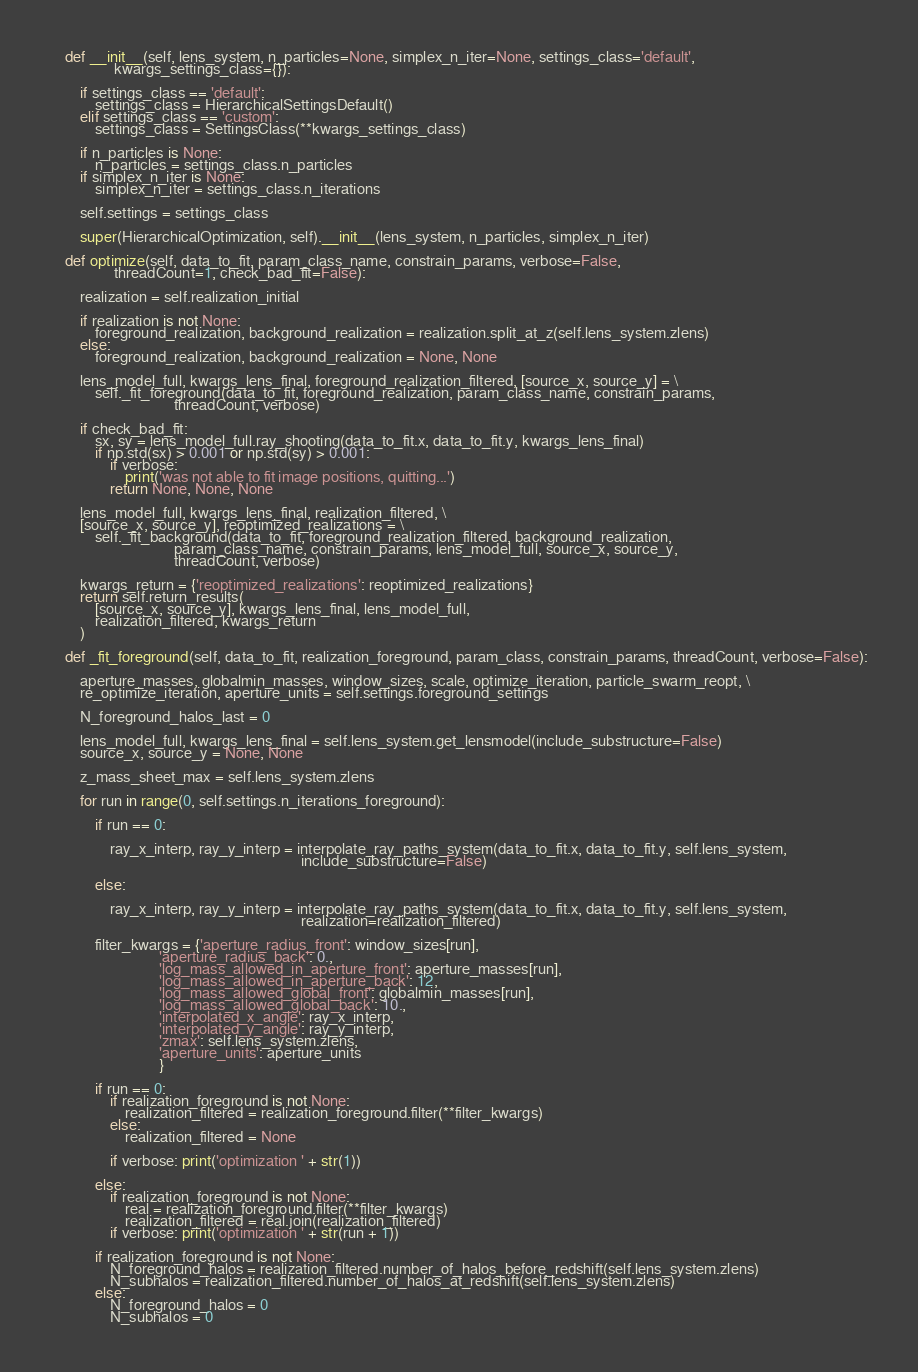<code> <loc_0><loc_0><loc_500><loc_500><_Python_>
    def __init__(self, lens_system, n_particles=None, simplex_n_iter=None, settings_class='default',
                 kwargs_settings_class={}):

        if settings_class == 'default':
            settings_class = HierarchicalSettingsDefault()
        elif settings_class == 'custom':
            settings_class = SettingsClass(**kwargs_settings_class)

        if n_particles is None:
            n_particles = settings_class.n_particles
        if simplex_n_iter is None:
            simplex_n_iter = settings_class.n_iterations

        self.settings = settings_class

        super(HierarchicalOptimization, self).__init__(lens_system, n_particles, simplex_n_iter)

    def optimize(self, data_to_fit, param_class_name, constrain_params, verbose=False,
                 threadCount=1, check_bad_fit=False):

        realization = self.realization_initial

        if realization is not None:
            foreground_realization, background_realization = realization.split_at_z(self.lens_system.zlens)
        else:
            foreground_realization, background_realization = None, None

        lens_model_full, kwargs_lens_final, foreground_realization_filtered, [source_x, source_y] = \
            self._fit_foreground(data_to_fit, foreground_realization, param_class_name, constrain_params,
                                 threadCount, verbose)

        if check_bad_fit:
            sx, sy = lens_model_full.ray_shooting(data_to_fit.x, data_to_fit.y, kwargs_lens_final)
            if np.std(sx) > 0.001 or np.std(sy) > 0.001:
                if verbose:
                    print('was not able to fit image positions, quitting...')
                return None, None, None

        lens_model_full, kwargs_lens_final, realization_filtered, \
        [source_x, source_y], reoptimized_realizations = \
            self._fit_background(data_to_fit, foreground_realization_filtered, background_realization,
                                 param_class_name, constrain_params, lens_model_full, source_x, source_y,
                                 threadCount, verbose)

        kwargs_return = {'reoptimized_realizations': reoptimized_realizations}
        return self.return_results(
            [source_x, source_y], kwargs_lens_final, lens_model_full,
            realization_filtered, kwargs_return
        )

    def _fit_foreground(self, data_to_fit, realization_foreground, param_class, constrain_params, threadCount, verbose=False):

        aperture_masses, globalmin_masses, window_sizes, scale, optimize_iteration, particle_swarm_reopt, \
        re_optimize_iteration, aperture_units = self.settings.foreground_settings

        N_foreground_halos_last = 0

        lens_model_full, kwargs_lens_final = self.lens_system.get_lensmodel(include_substructure=False)
        source_x, source_y = None, None

        z_mass_sheet_max = self.lens_system.zlens

        for run in range(0, self.settings.n_iterations_foreground):

            if run == 0:

                ray_x_interp, ray_y_interp = interpolate_ray_paths_system(data_to_fit.x, data_to_fit.y, self.lens_system,
                                                                   include_substructure=False)

            else:

                ray_x_interp, ray_y_interp = interpolate_ray_paths_system(data_to_fit.x, data_to_fit.y, self.lens_system,
                                                                   realization=realization_filtered)

            filter_kwargs = {'aperture_radius_front': window_sizes[run],
                             'aperture_radius_back': 0.,
                             'log_mass_allowed_in_aperture_front': aperture_masses[run],
                             'log_mass_allowed_in_aperture_back': 12,
                             'log_mass_allowed_global_front': globalmin_masses[run],
                             'log_mass_allowed_global_back': 10.,
                             'interpolated_x_angle': ray_x_interp,
                             'interpolated_y_angle': ray_y_interp,
                             'zmax': self.lens_system.zlens,
                             'aperture_units': aperture_units
                             }

            if run == 0:
                if realization_foreground is not None:
                    realization_filtered = realization_foreground.filter(**filter_kwargs)
                else:
                    realization_filtered = None

                if verbose: print('optimization ' + str(1))

            else:
                if realization_foreground is not None:
                    real = realization_foreground.filter(**filter_kwargs)
                    realization_filtered = real.join(realization_filtered)
                if verbose: print('optimization ' + str(run + 1))

            if realization_foreground is not None:
                N_foreground_halos = realization_filtered.number_of_halos_before_redshift(self.lens_system.zlens)
                N_subhalos = realization_filtered.number_of_halos_at_redshift(self.lens_system.zlens)
            else:
                N_foreground_halos = 0
                N_subhalos = 0
</code> 